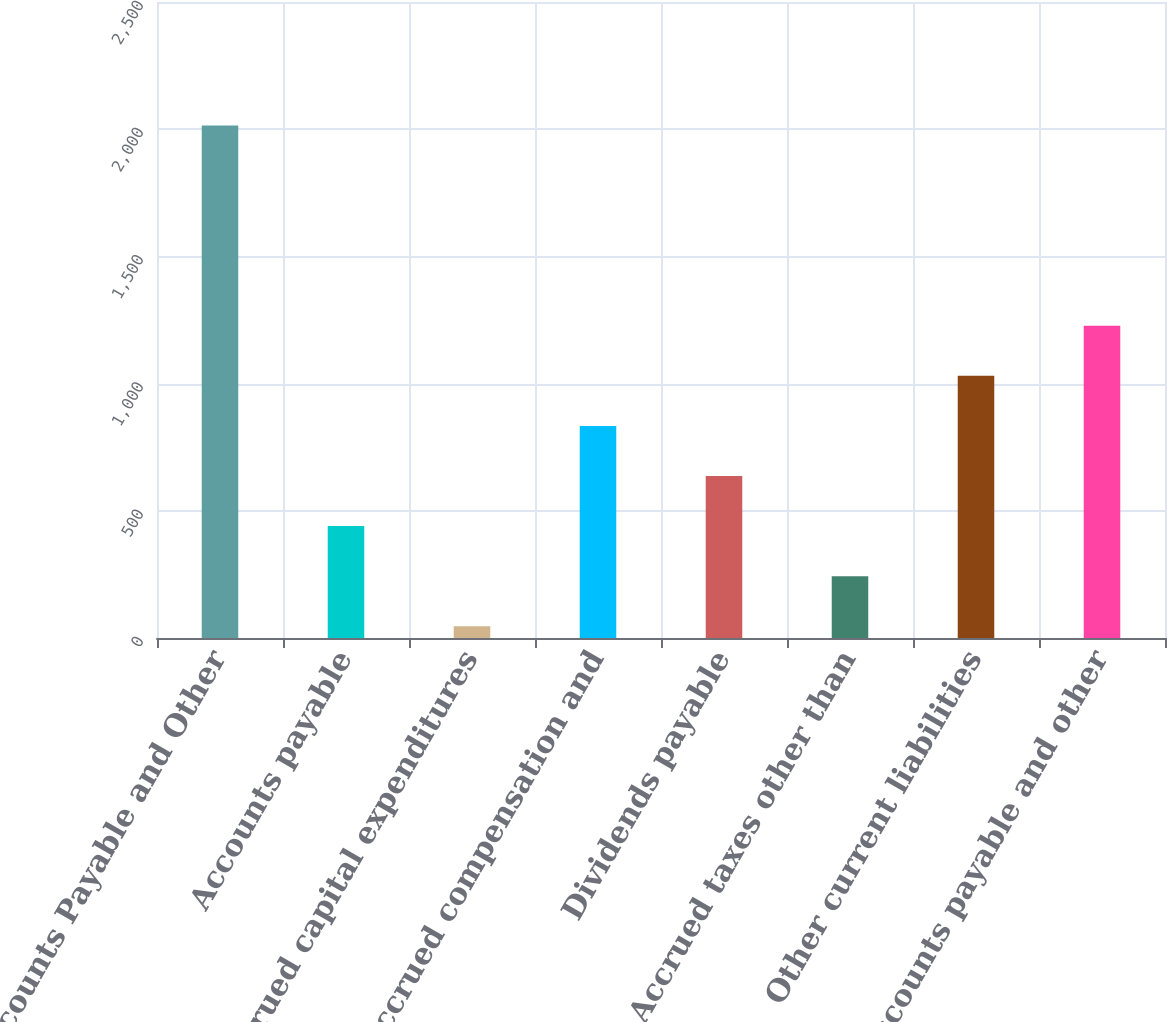Convert chart. <chart><loc_0><loc_0><loc_500><loc_500><bar_chart><fcel>Accounts Payable and Other<fcel>Accounts payable<fcel>Accrued capital expenditures<fcel>Accrued compensation and<fcel>Dividends payable<fcel>Accrued taxes other than<fcel>Other current liabilities<fcel>Accounts payable and other<nl><fcel>2015<fcel>439.8<fcel>46<fcel>833.6<fcel>636.7<fcel>242.9<fcel>1030.5<fcel>1227.4<nl></chart> 